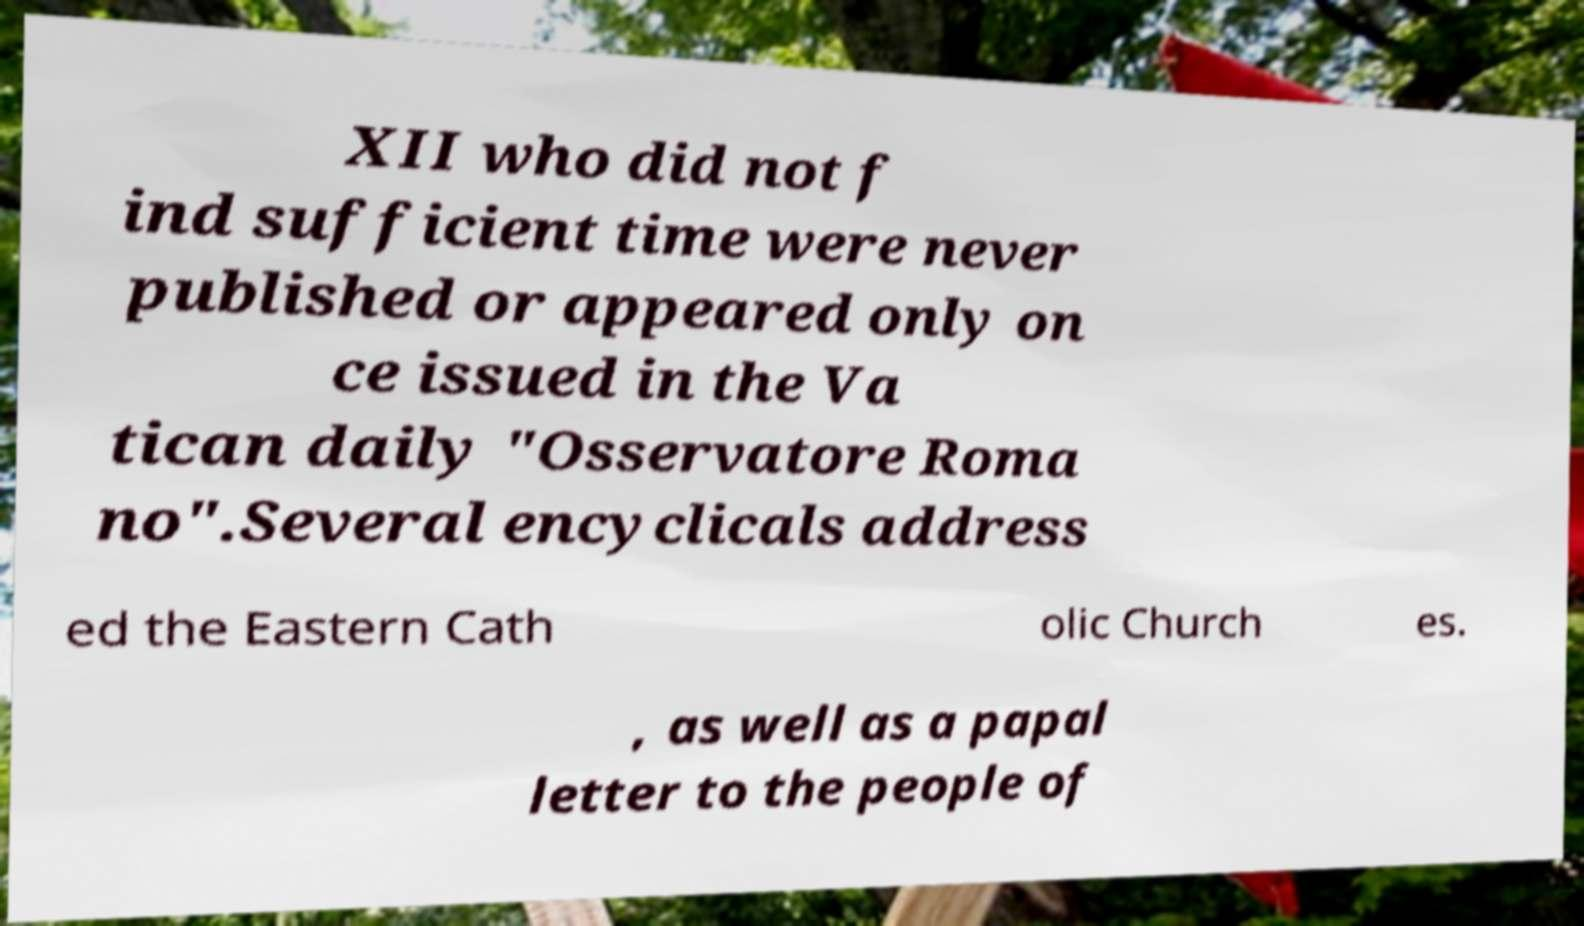Please identify and transcribe the text found in this image. XII who did not f ind sufficient time were never published or appeared only on ce issued in the Va tican daily "Osservatore Roma no".Several encyclicals address ed the Eastern Cath olic Church es. , as well as a papal letter to the people of 